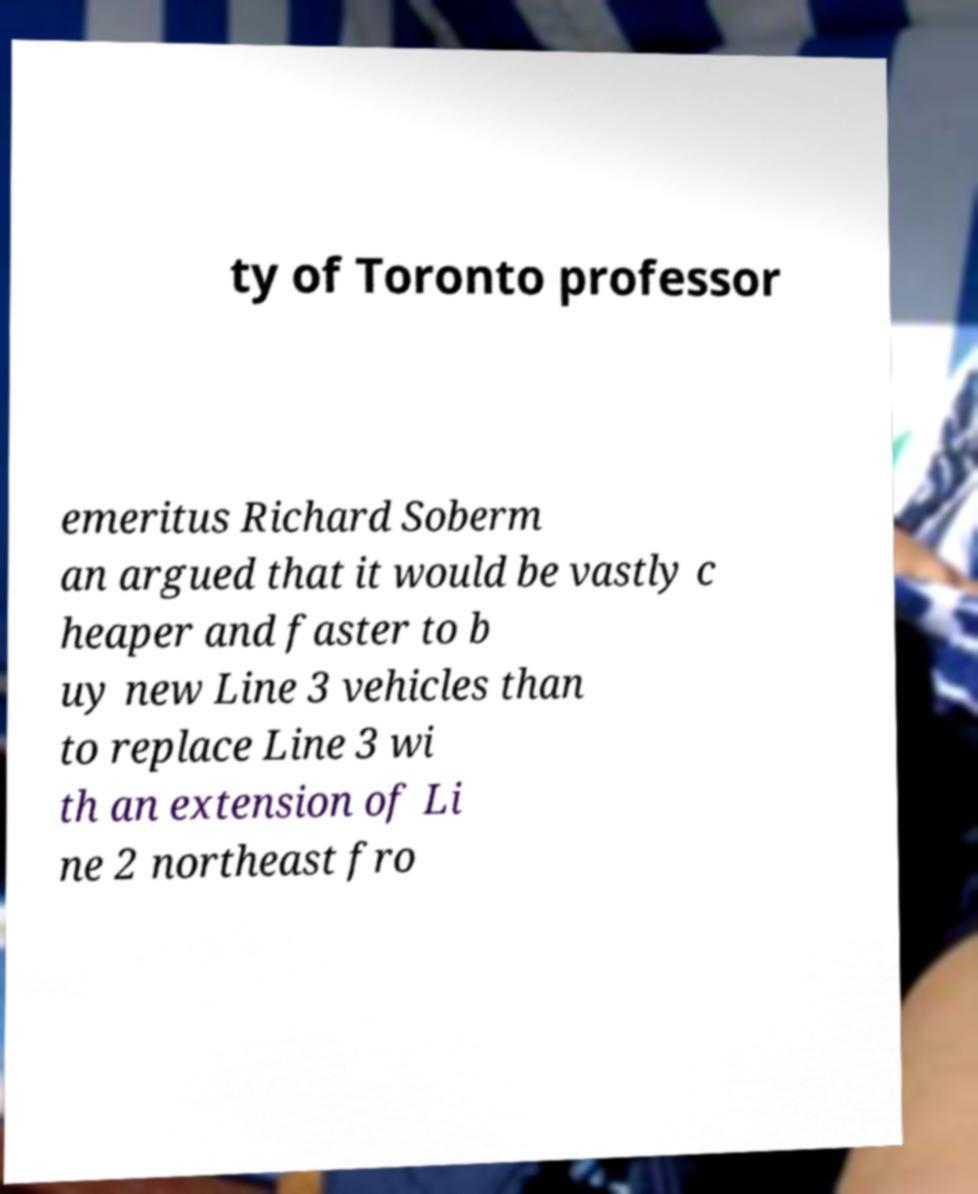I need the written content from this picture converted into text. Can you do that? ty of Toronto professor emeritus Richard Soberm an argued that it would be vastly c heaper and faster to b uy new Line 3 vehicles than to replace Line 3 wi th an extension of Li ne 2 northeast fro 